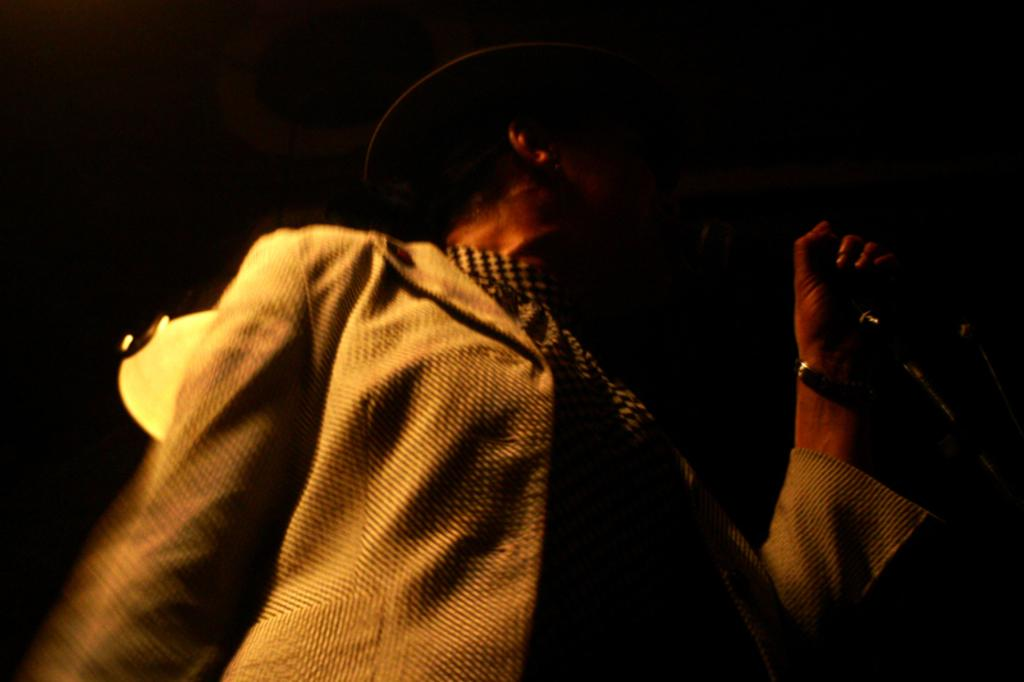Who is the main subject in the image? There is a man in the picture. What is the man wearing on his head? The man is wearing a hat. What type of clothing is the man wearing on his upper body? The man is wearing a jacket. What object is the man holding in his hand? The man is holding a microphone. What type of fog can be seen in the background of the image? There is no fog visible in the image; it is a picture of a man wearing a hat, jacket, and holding a microphone. 